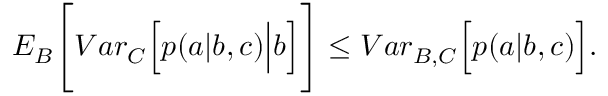Convert formula to latex. <formula><loc_0><loc_0><loc_500><loc_500>\begin{array} { r } { { E } _ { B } \Big [ { V a r } _ { C } \Big [ p ( a | b , c ) \Big | b \Big ] \Big ] \leq { V a r } _ { B , C } \Big [ p ( a | b , c ) \Big ] . } \end{array}</formula> 